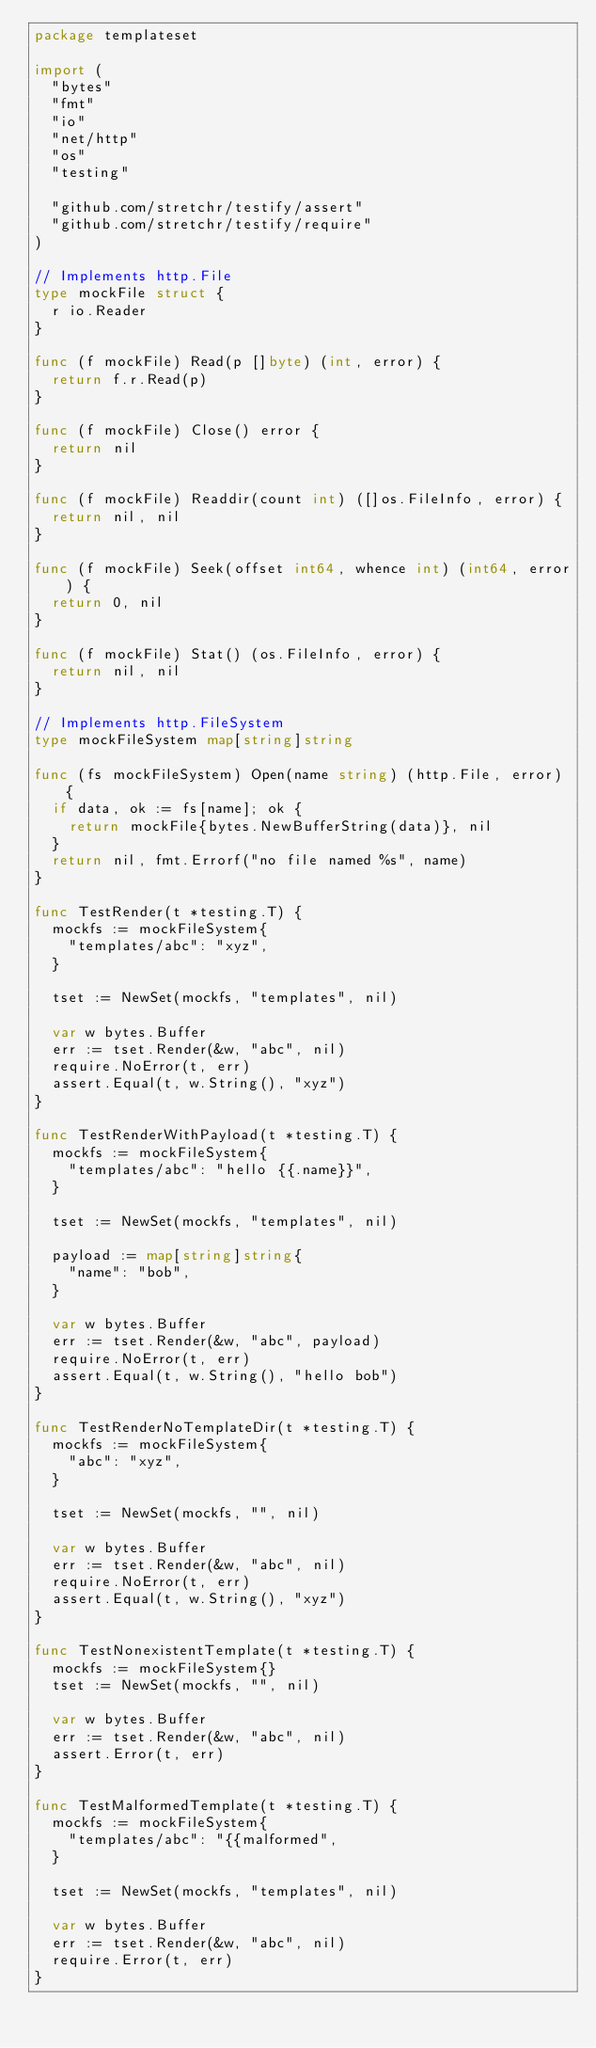Convert code to text. <code><loc_0><loc_0><loc_500><loc_500><_Go_>package templateset

import (
	"bytes"
	"fmt"
	"io"
	"net/http"
	"os"
	"testing"

	"github.com/stretchr/testify/assert"
	"github.com/stretchr/testify/require"
)

// Implements http.File
type mockFile struct {
	r io.Reader
}

func (f mockFile) Read(p []byte) (int, error) {
	return f.r.Read(p)
}

func (f mockFile) Close() error {
	return nil
}

func (f mockFile) Readdir(count int) ([]os.FileInfo, error) {
	return nil, nil
}

func (f mockFile) Seek(offset int64, whence int) (int64, error) {
	return 0, nil
}

func (f mockFile) Stat() (os.FileInfo, error) {
	return nil, nil
}

// Implements http.FileSystem
type mockFileSystem map[string]string

func (fs mockFileSystem) Open(name string) (http.File, error) {
	if data, ok := fs[name]; ok {
		return mockFile{bytes.NewBufferString(data)}, nil
	}
	return nil, fmt.Errorf("no file named %s", name)
}

func TestRender(t *testing.T) {
	mockfs := mockFileSystem{
		"templates/abc": "xyz",
	}

	tset := NewSet(mockfs, "templates", nil)

	var w bytes.Buffer
	err := tset.Render(&w, "abc", nil)
	require.NoError(t, err)
	assert.Equal(t, w.String(), "xyz")
}

func TestRenderWithPayload(t *testing.T) {
	mockfs := mockFileSystem{
		"templates/abc": "hello {{.name}}",
	}

	tset := NewSet(mockfs, "templates", nil)

	payload := map[string]string{
		"name": "bob",
	}

	var w bytes.Buffer
	err := tset.Render(&w, "abc", payload)
	require.NoError(t, err)
	assert.Equal(t, w.String(), "hello bob")
}

func TestRenderNoTemplateDir(t *testing.T) {
	mockfs := mockFileSystem{
		"abc": "xyz",
	}

	tset := NewSet(mockfs, "", nil)

	var w bytes.Buffer
	err := tset.Render(&w, "abc", nil)
	require.NoError(t, err)
	assert.Equal(t, w.String(), "xyz")
}

func TestNonexistentTemplate(t *testing.T) {
	mockfs := mockFileSystem{}
	tset := NewSet(mockfs, "", nil)

	var w bytes.Buffer
	err := tset.Render(&w, "abc", nil)
	assert.Error(t, err)
}

func TestMalformedTemplate(t *testing.T) {
	mockfs := mockFileSystem{
		"templates/abc": "{{malformed",
	}

	tset := NewSet(mockfs, "templates", nil)

	var w bytes.Buffer
	err := tset.Render(&w, "abc", nil)
	require.Error(t, err)
}
</code> 